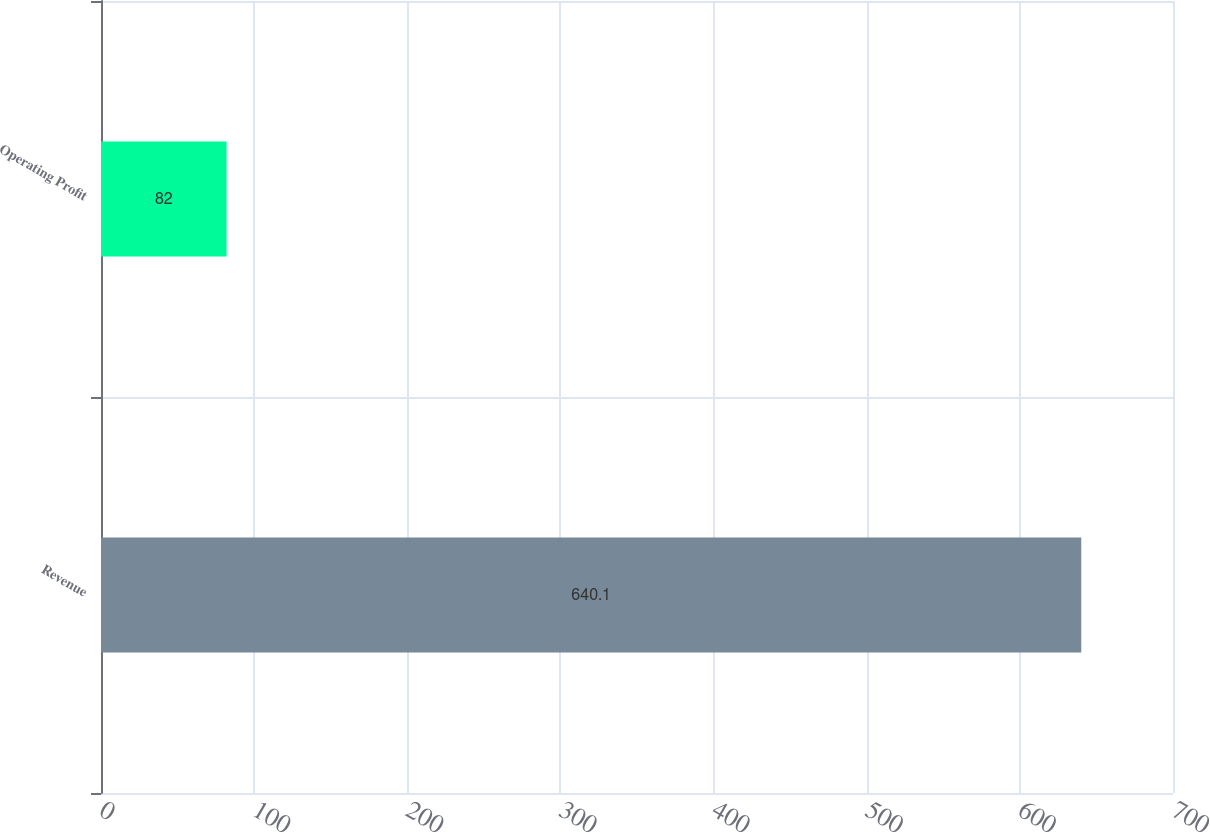Convert chart. <chart><loc_0><loc_0><loc_500><loc_500><bar_chart><fcel>Revenue<fcel>Operating Profit<nl><fcel>640.1<fcel>82<nl></chart> 